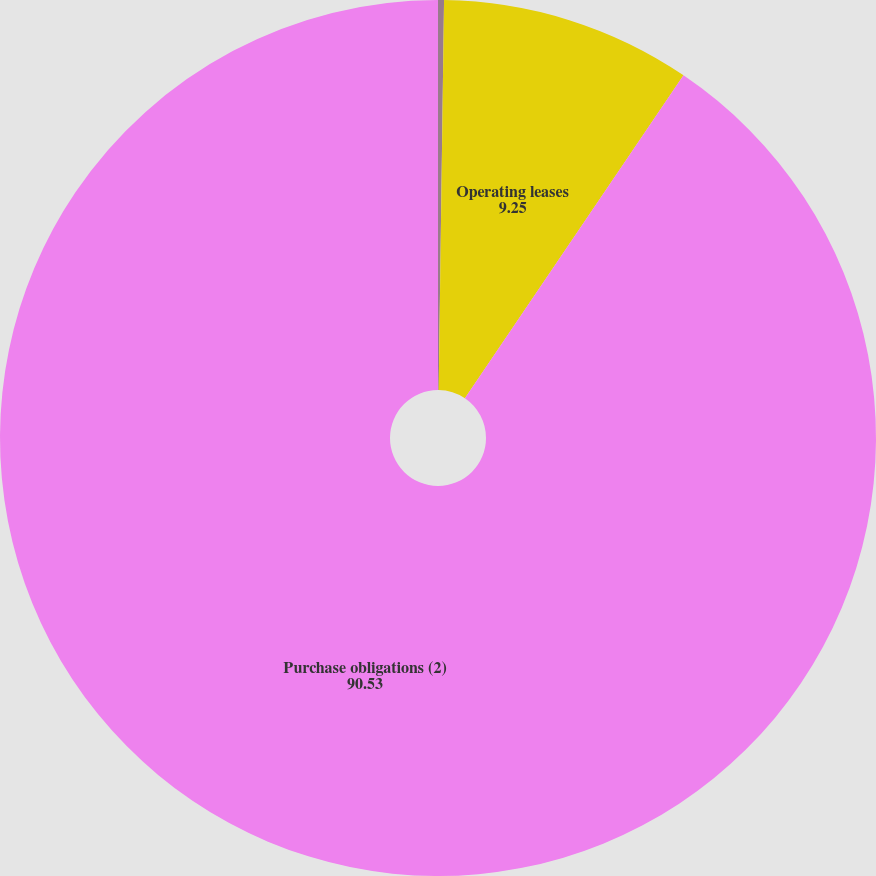Convert chart. <chart><loc_0><loc_0><loc_500><loc_500><pie_chart><fcel>Capital lease payments<fcel>Operating leases<fcel>Purchase obligations (2)<nl><fcel>0.22%<fcel>9.25%<fcel>90.53%<nl></chart> 